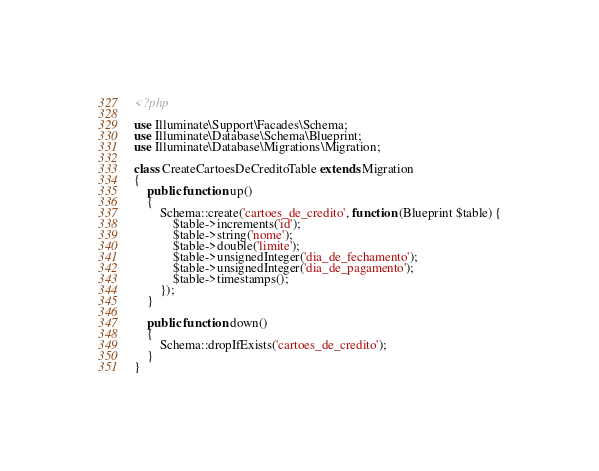<code> <loc_0><loc_0><loc_500><loc_500><_PHP_><?php

use Illuminate\Support\Facades\Schema;
use Illuminate\Database\Schema\Blueprint;
use Illuminate\Database\Migrations\Migration;

class CreateCartoesDeCreditoTable extends Migration
{
    public function up()
    {
        Schema::create('cartoes_de_credito', function (Blueprint $table) {
            $table->increments('id');
            $table->string('nome');
            $table->double('limite');
            $table->unsignedInteger('dia_de_fechamento');
            $table->unsignedInteger('dia_de_pagamento');
            $table->timestamps();
        });
    }

    public function down()
    {
        Schema::dropIfExists('cartoes_de_credito');
    }
}
</code> 